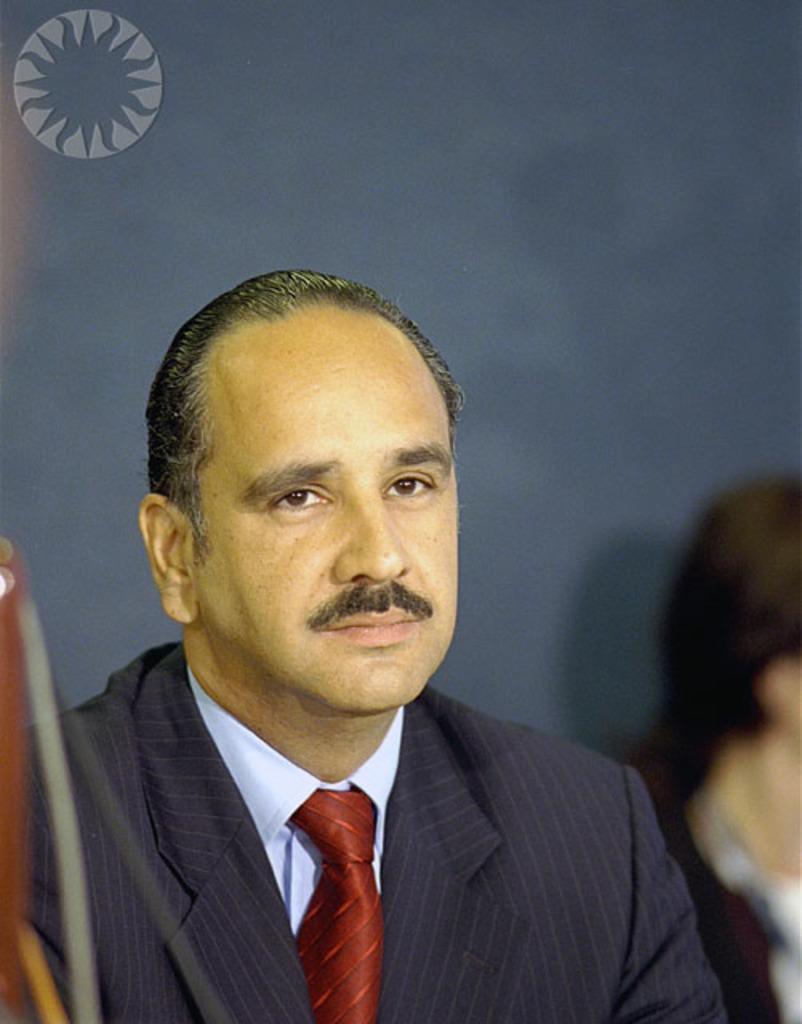Describe this image in one or two sentences. In this picture we can see a man in the blazer. Behind the man there is the blurred background. On the image there is a watermark. 